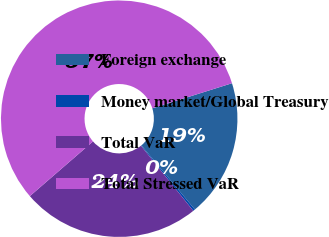Convert chart. <chart><loc_0><loc_0><loc_500><loc_500><pie_chart><fcel>Foreign exchange<fcel>Money market/Global Treasury<fcel>Total VaR<fcel>Total Stressed VaR<nl><fcel>18.79%<fcel>0.28%<fcel>24.42%<fcel>56.51%<nl></chart> 